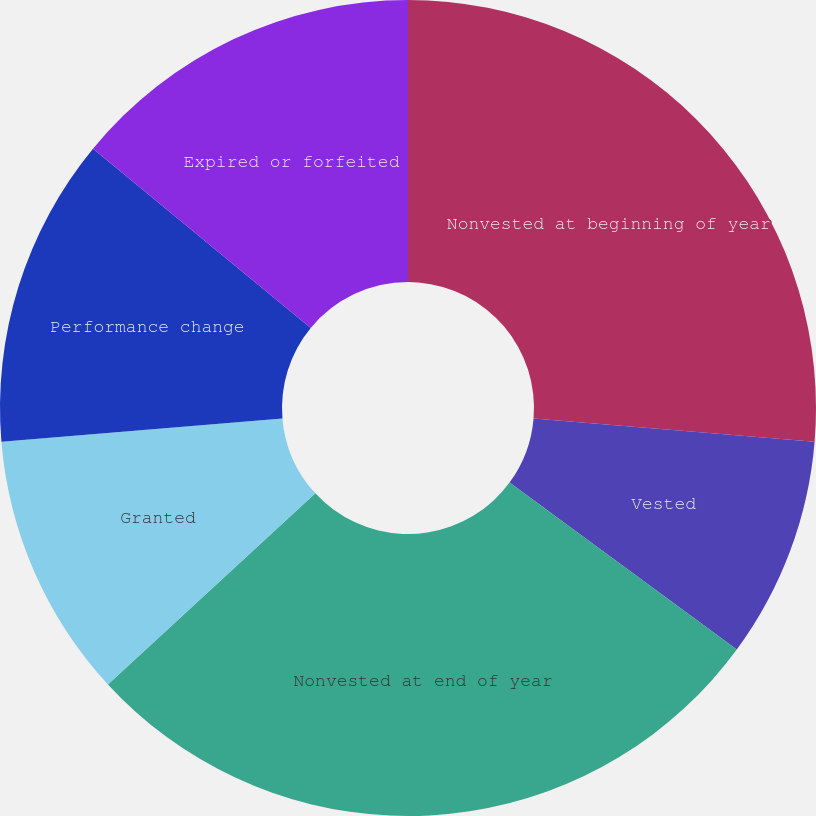<chart> <loc_0><loc_0><loc_500><loc_500><pie_chart><fcel>Nonvested at beginning of year<fcel>Vested<fcel>Nonvested at end of year<fcel>Granted<fcel>Performance change<fcel>Expired or forfeited<nl><fcel>26.32%<fcel>8.77%<fcel>28.07%<fcel>10.53%<fcel>12.28%<fcel>14.04%<nl></chart> 